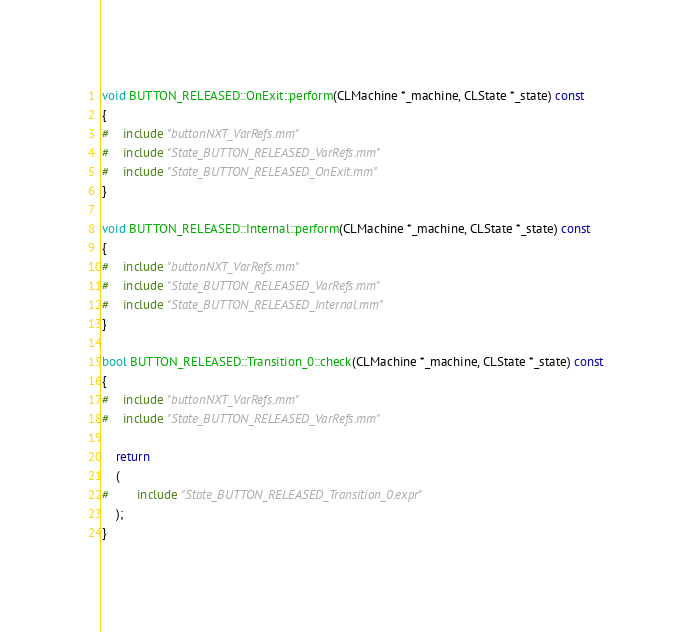Convert code to text. <code><loc_0><loc_0><loc_500><loc_500><_ObjectiveC_>
void BUTTON_RELEASED::OnExit::perform(CLMachine *_machine, CLState *_state) const
{
#	include "buttonNXT_VarRefs.mm"
#	include "State_BUTTON_RELEASED_VarRefs.mm"
#	include "State_BUTTON_RELEASED_OnExit.mm"
}

void BUTTON_RELEASED::Internal::perform(CLMachine *_machine, CLState *_state) const
{
#	include "buttonNXT_VarRefs.mm"
#	include "State_BUTTON_RELEASED_VarRefs.mm"
#	include "State_BUTTON_RELEASED_Internal.mm"
}

bool BUTTON_RELEASED::Transition_0::check(CLMachine *_machine, CLState *_state) const
{
#	include "buttonNXT_VarRefs.mm"
#	include "State_BUTTON_RELEASED_VarRefs.mm"

	return
	(
#		include "State_BUTTON_RELEASED_Transition_0.expr"
	);
}
</code> 